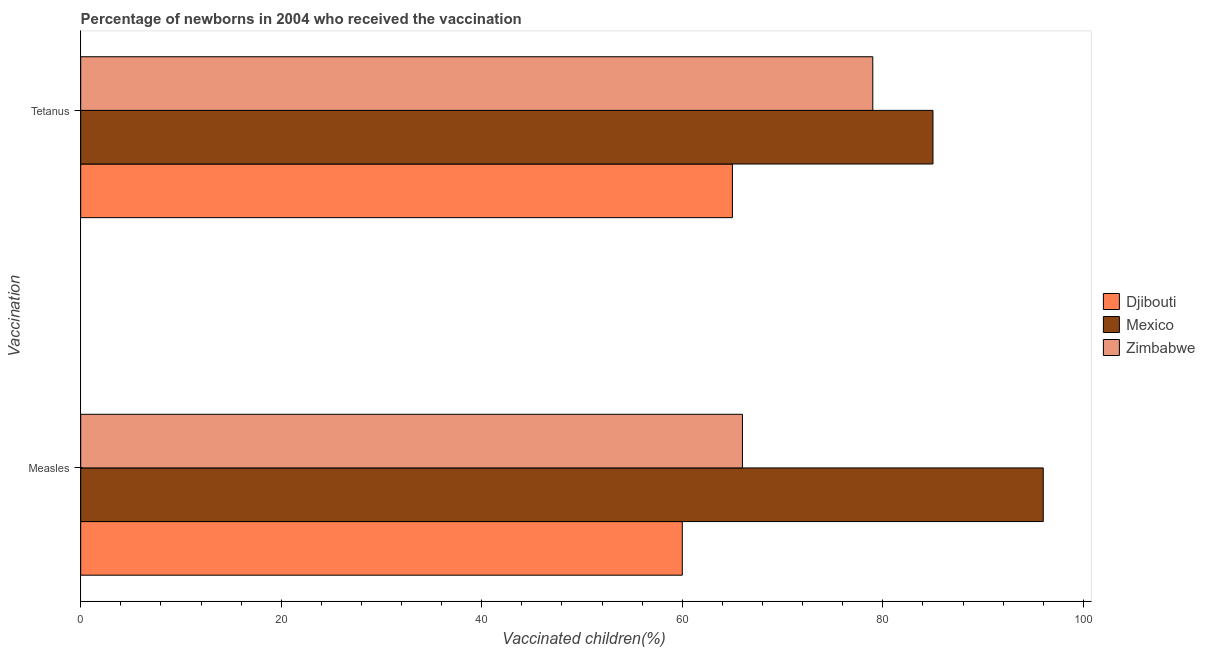How many different coloured bars are there?
Ensure brevity in your answer.  3. How many bars are there on the 1st tick from the bottom?
Offer a terse response. 3. What is the label of the 1st group of bars from the top?
Keep it short and to the point. Tetanus. What is the percentage of newborns who received vaccination for measles in Djibouti?
Ensure brevity in your answer.  60. Across all countries, what is the maximum percentage of newborns who received vaccination for tetanus?
Your response must be concise. 85. Across all countries, what is the minimum percentage of newborns who received vaccination for measles?
Provide a succinct answer. 60. In which country was the percentage of newborns who received vaccination for tetanus minimum?
Your answer should be compact. Djibouti. What is the total percentage of newborns who received vaccination for tetanus in the graph?
Provide a short and direct response. 229. What is the difference between the percentage of newborns who received vaccination for tetanus in Mexico and the percentage of newborns who received vaccination for measles in Zimbabwe?
Offer a very short reply. 19. What is the difference between the percentage of newborns who received vaccination for measles and percentage of newborns who received vaccination for tetanus in Djibouti?
Your answer should be compact. -5. What is the ratio of the percentage of newborns who received vaccination for measles in Mexico to that in Zimbabwe?
Your answer should be compact. 1.45. Is the percentage of newborns who received vaccination for measles in Djibouti less than that in Zimbabwe?
Your response must be concise. Yes. In how many countries, is the percentage of newborns who received vaccination for measles greater than the average percentage of newborns who received vaccination for measles taken over all countries?
Offer a terse response. 1. What does the 2nd bar from the top in Measles represents?
Your answer should be compact. Mexico. What does the 3rd bar from the bottom in Measles represents?
Offer a terse response. Zimbabwe. How many bars are there?
Provide a succinct answer. 6. How many countries are there in the graph?
Keep it short and to the point. 3. What is the difference between two consecutive major ticks on the X-axis?
Your answer should be compact. 20. What is the title of the graph?
Offer a terse response. Percentage of newborns in 2004 who received the vaccination. Does "Costa Rica" appear as one of the legend labels in the graph?
Provide a short and direct response. No. What is the label or title of the X-axis?
Your answer should be compact. Vaccinated children(%)
. What is the label or title of the Y-axis?
Offer a terse response. Vaccination. What is the Vaccinated children(%)
 in Djibouti in Measles?
Keep it short and to the point. 60. What is the Vaccinated children(%)
 in Mexico in Measles?
Your answer should be very brief. 96. What is the Vaccinated children(%)
 in Zimbabwe in Measles?
Your answer should be very brief. 66. What is the Vaccinated children(%)
 in Mexico in Tetanus?
Ensure brevity in your answer.  85. What is the Vaccinated children(%)
 in Zimbabwe in Tetanus?
Your answer should be very brief. 79. Across all Vaccination, what is the maximum Vaccinated children(%)
 in Mexico?
Provide a short and direct response. 96. Across all Vaccination, what is the maximum Vaccinated children(%)
 in Zimbabwe?
Your response must be concise. 79. Across all Vaccination, what is the minimum Vaccinated children(%)
 of Zimbabwe?
Provide a short and direct response. 66. What is the total Vaccinated children(%)
 in Djibouti in the graph?
Your response must be concise. 125. What is the total Vaccinated children(%)
 of Mexico in the graph?
Your answer should be compact. 181. What is the total Vaccinated children(%)
 in Zimbabwe in the graph?
Offer a terse response. 145. What is the difference between the Vaccinated children(%)
 of Djibouti in Measles and that in Tetanus?
Offer a very short reply. -5. What is the difference between the Vaccinated children(%)
 in Mexico in Measles and that in Tetanus?
Provide a short and direct response. 11. What is the difference between the Vaccinated children(%)
 of Zimbabwe in Measles and that in Tetanus?
Make the answer very short. -13. What is the difference between the Vaccinated children(%)
 of Djibouti in Measles and the Vaccinated children(%)
 of Mexico in Tetanus?
Provide a succinct answer. -25. What is the average Vaccinated children(%)
 in Djibouti per Vaccination?
Provide a short and direct response. 62.5. What is the average Vaccinated children(%)
 in Mexico per Vaccination?
Provide a short and direct response. 90.5. What is the average Vaccinated children(%)
 of Zimbabwe per Vaccination?
Ensure brevity in your answer.  72.5. What is the difference between the Vaccinated children(%)
 of Djibouti and Vaccinated children(%)
 of Mexico in Measles?
Your response must be concise. -36. What is the difference between the Vaccinated children(%)
 of Djibouti and Vaccinated children(%)
 of Zimbabwe in Measles?
Give a very brief answer. -6. What is the difference between the Vaccinated children(%)
 in Djibouti and Vaccinated children(%)
 in Mexico in Tetanus?
Your answer should be very brief. -20. What is the difference between the Vaccinated children(%)
 of Djibouti and Vaccinated children(%)
 of Zimbabwe in Tetanus?
Offer a terse response. -14. What is the difference between the Vaccinated children(%)
 in Mexico and Vaccinated children(%)
 in Zimbabwe in Tetanus?
Make the answer very short. 6. What is the ratio of the Vaccinated children(%)
 of Mexico in Measles to that in Tetanus?
Keep it short and to the point. 1.13. What is the ratio of the Vaccinated children(%)
 of Zimbabwe in Measles to that in Tetanus?
Offer a terse response. 0.84. What is the difference between the highest and the second highest Vaccinated children(%)
 of Mexico?
Give a very brief answer. 11. What is the difference between the highest and the second highest Vaccinated children(%)
 of Zimbabwe?
Provide a short and direct response. 13. What is the difference between the highest and the lowest Vaccinated children(%)
 in Zimbabwe?
Keep it short and to the point. 13. 